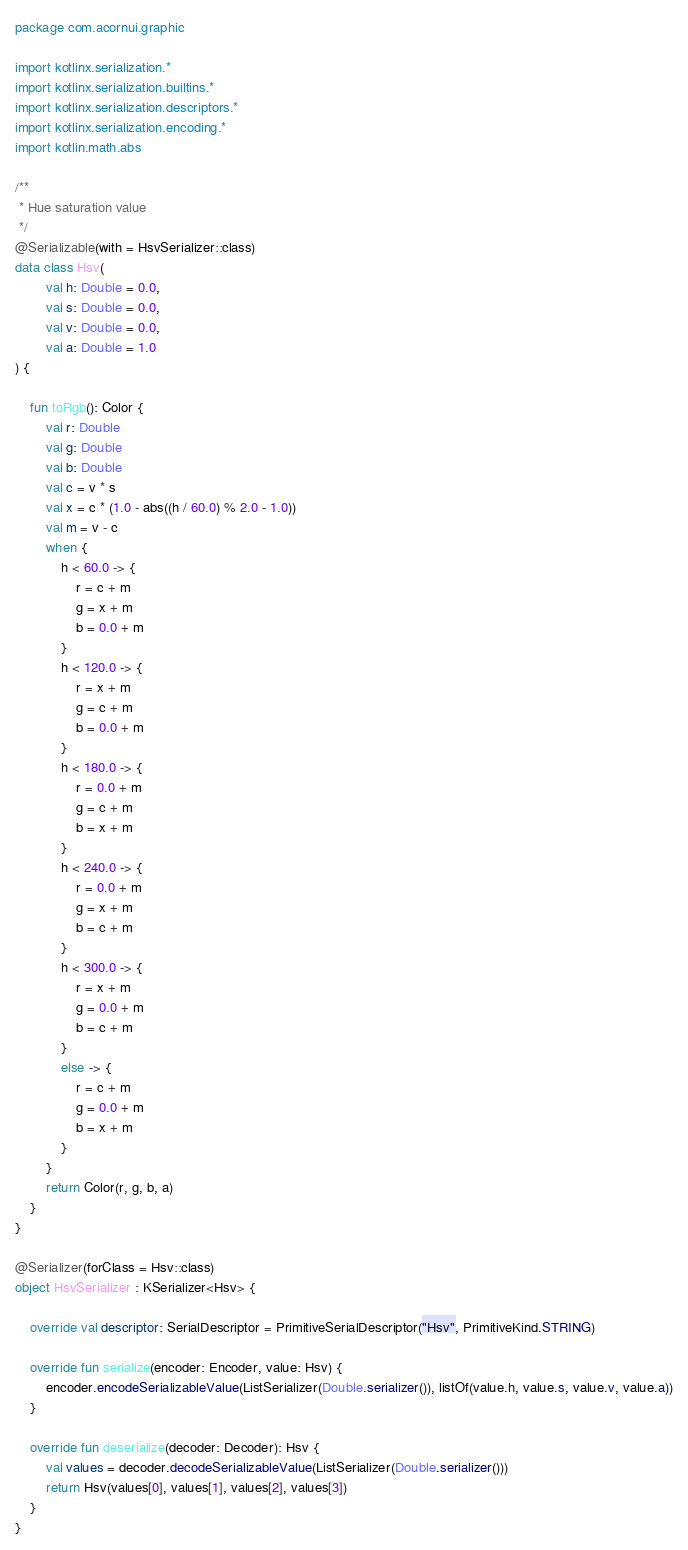Convert code to text. <code><loc_0><loc_0><loc_500><loc_500><_Kotlin_>package com.acornui.graphic

import kotlinx.serialization.*
import kotlinx.serialization.builtins.*
import kotlinx.serialization.descriptors.*
import kotlinx.serialization.encoding.*
import kotlin.math.abs

/**
 * Hue saturation value
 */
@Serializable(with = HsvSerializer::class)
data class Hsv(
		val h: Double = 0.0,
		val s: Double = 0.0,
		val v: Double = 0.0,
		val a: Double = 1.0
) {

	fun toRgb(): Color {
		val r: Double
		val g: Double
		val b: Double
		val c = v * s
		val x = c * (1.0 - abs((h / 60.0) % 2.0 - 1.0))
		val m = v - c
		when {
			h < 60.0 -> {
				r = c + m
				g = x + m
				b = 0.0 + m
			}
			h < 120.0 -> {
				r = x + m
				g = c + m
				b = 0.0 + m
			}
			h < 180.0 -> {
				r = 0.0 + m
				g = c + m
				b = x + m
			}
			h < 240.0 -> {
				r = 0.0 + m
				g = x + m
				b = c + m
			}
			h < 300.0 -> {
				r = x + m
				g = 0.0 + m
				b = c + m
			}
			else -> {
				r = c + m
				g = 0.0 + m
				b = x + m
			}
		}
		return Color(r, g, b, a)
	}
}

@Serializer(forClass = Hsv::class)
object HsvSerializer : KSerializer<Hsv> {

	override val descriptor: SerialDescriptor = PrimitiveSerialDescriptor("Hsv", PrimitiveKind.STRING)
	
	override fun serialize(encoder: Encoder, value: Hsv) {
		encoder.encodeSerializableValue(ListSerializer(Double.serializer()), listOf(value.h, value.s, value.v, value.a))
	}

	override fun deserialize(decoder: Decoder): Hsv {
		val values = decoder.decodeSerializableValue(ListSerializer(Double.serializer()))
		return Hsv(values[0], values[1], values[2], values[3])
	}
}</code> 